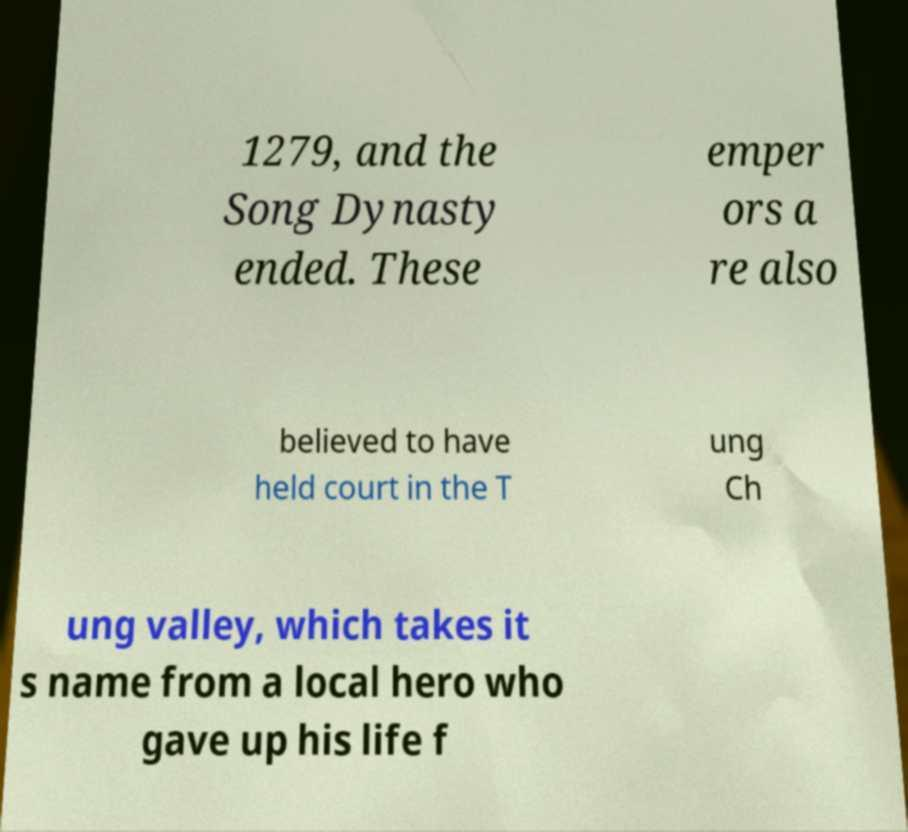Can you read and provide the text displayed in the image?This photo seems to have some interesting text. Can you extract and type it out for me? 1279, and the Song Dynasty ended. These emper ors a re also believed to have held court in the T ung Ch ung valley, which takes it s name from a local hero who gave up his life f 